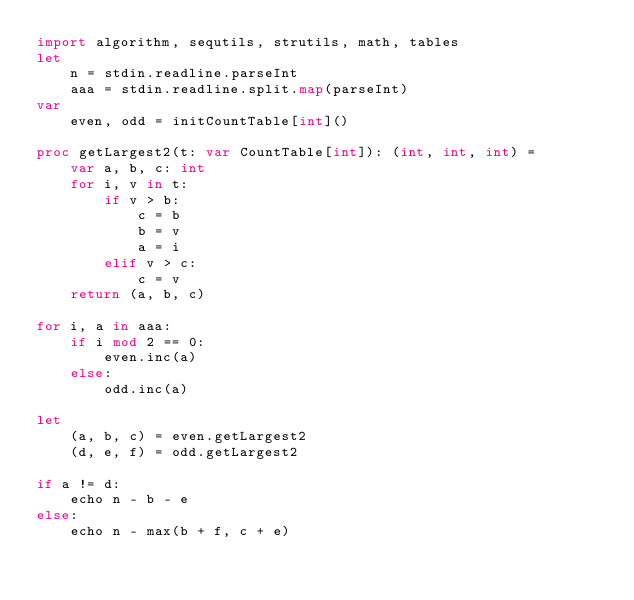<code> <loc_0><loc_0><loc_500><loc_500><_Nim_>import algorithm, sequtils, strutils, math, tables
let
    n = stdin.readline.parseInt
    aaa = stdin.readline.split.map(parseInt)
var
    even, odd = initCountTable[int]()

proc getLargest2(t: var CountTable[int]): (int, int, int) =
    var a, b, c: int
    for i, v in t:
        if v > b:
            c = b
            b = v
            a = i
        elif v > c:
            c = v
    return (a, b, c)

for i, a in aaa:
    if i mod 2 == 0:
        even.inc(a)
    else:
        odd.inc(a)

let
    (a, b, c) = even.getLargest2
    (d, e, f) = odd.getLargest2

if a != d:
    echo n - b - e
else:
    echo n - max(b + f, c + e)
</code> 